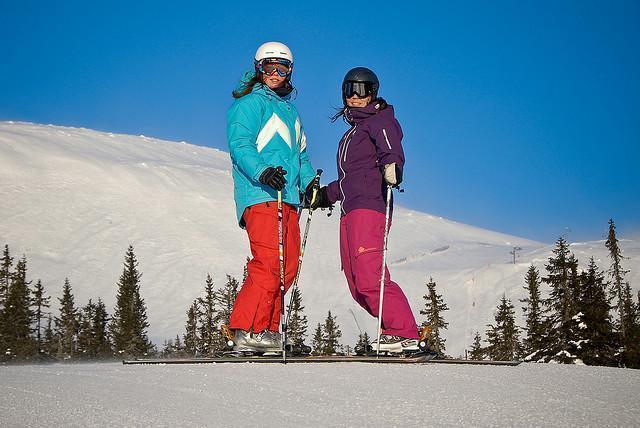What's the weather like for these skiers?
Indicate the correct response by choosing from the four available options to answer the question.
Options: Clear, stormy, cloudy, rainy. Clear. 